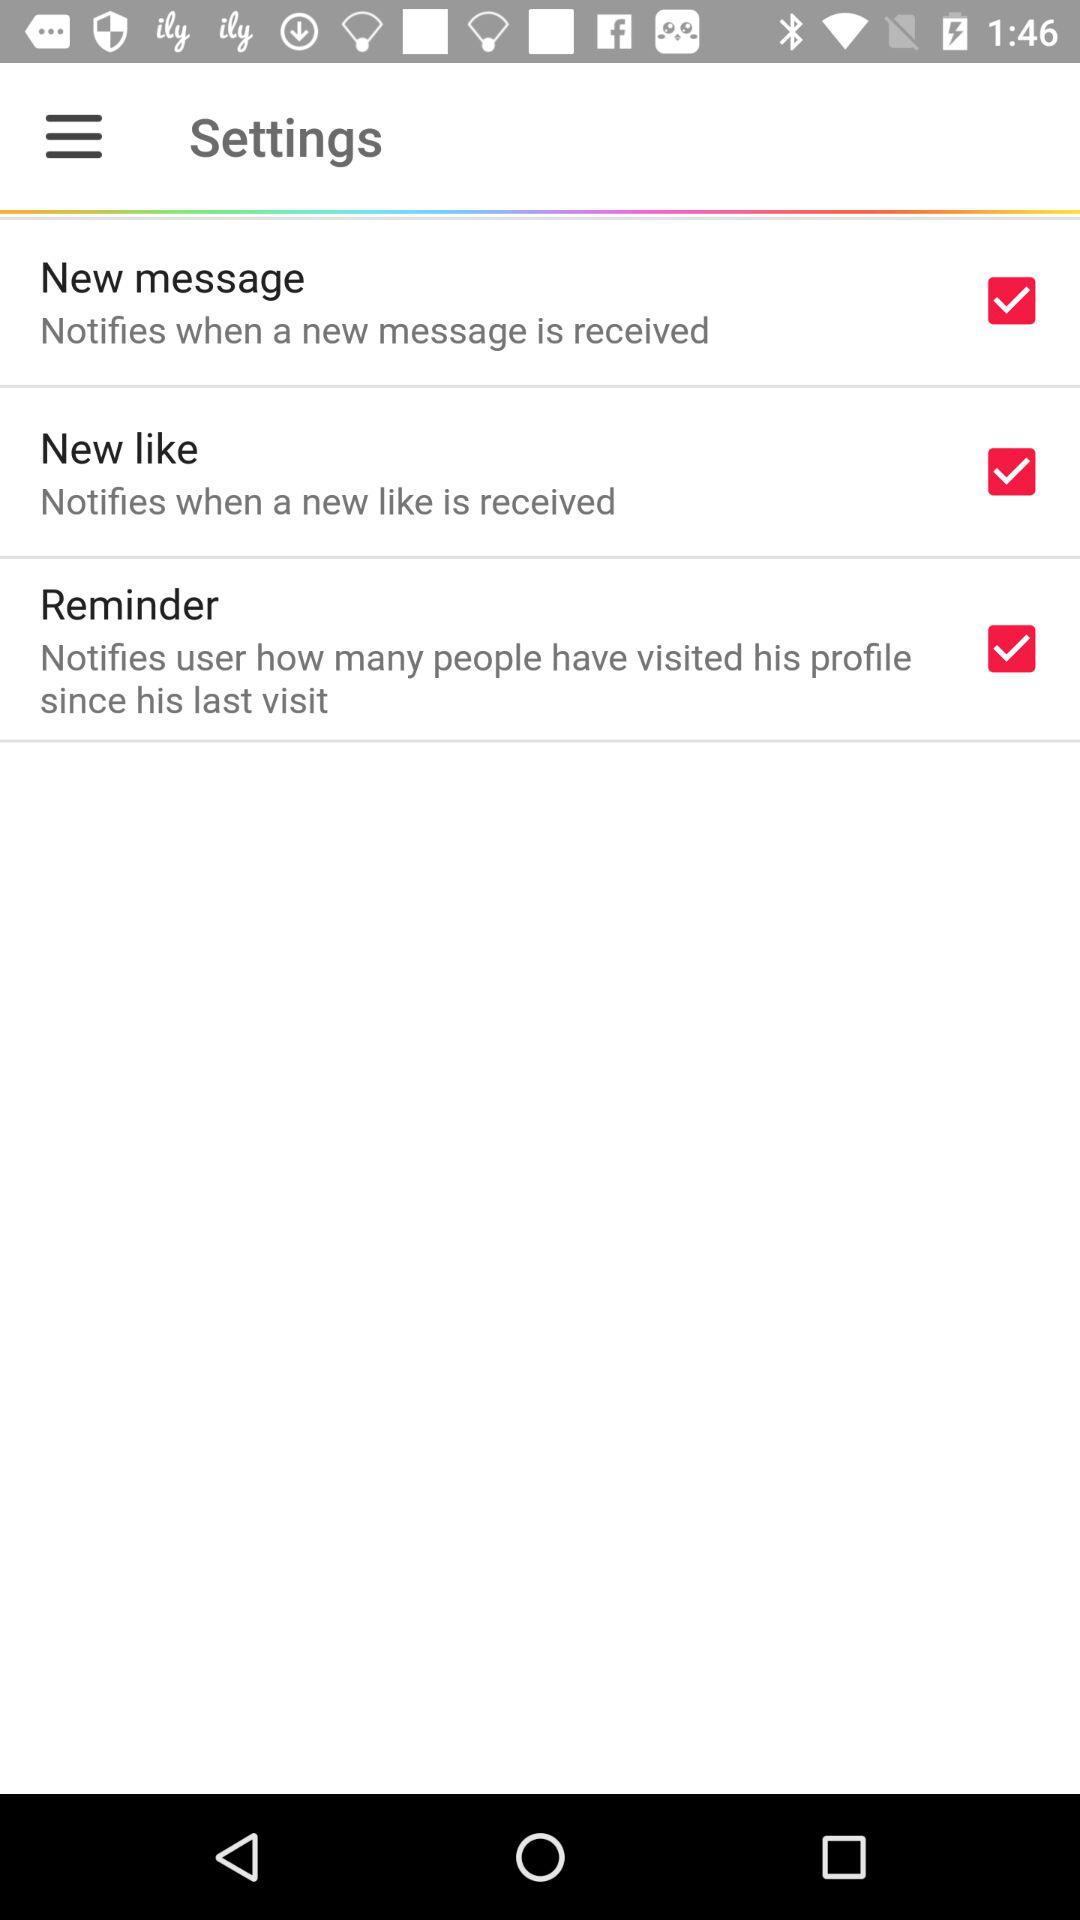How many notifications are there in total?
Answer the question using a single word or phrase. 3 